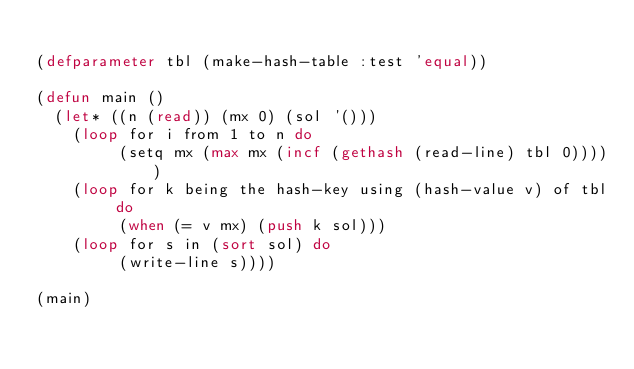<code> <loc_0><loc_0><loc_500><loc_500><_Lisp_>
(defparameter tbl (make-hash-table :test 'equal))

(defun main ()
  (let* ((n (read)) (mx 0) (sol '()))
    (loop for i from 1 to n do
         (setq mx (max mx (incf (gethash (read-line) tbl 0)))))
    (loop for k being the hash-key using (hash-value v) of tbl do
         (when (= v mx) (push k sol)))
    (loop for s in (sort sol) do
         (write-line s))))

(main)
</code> 